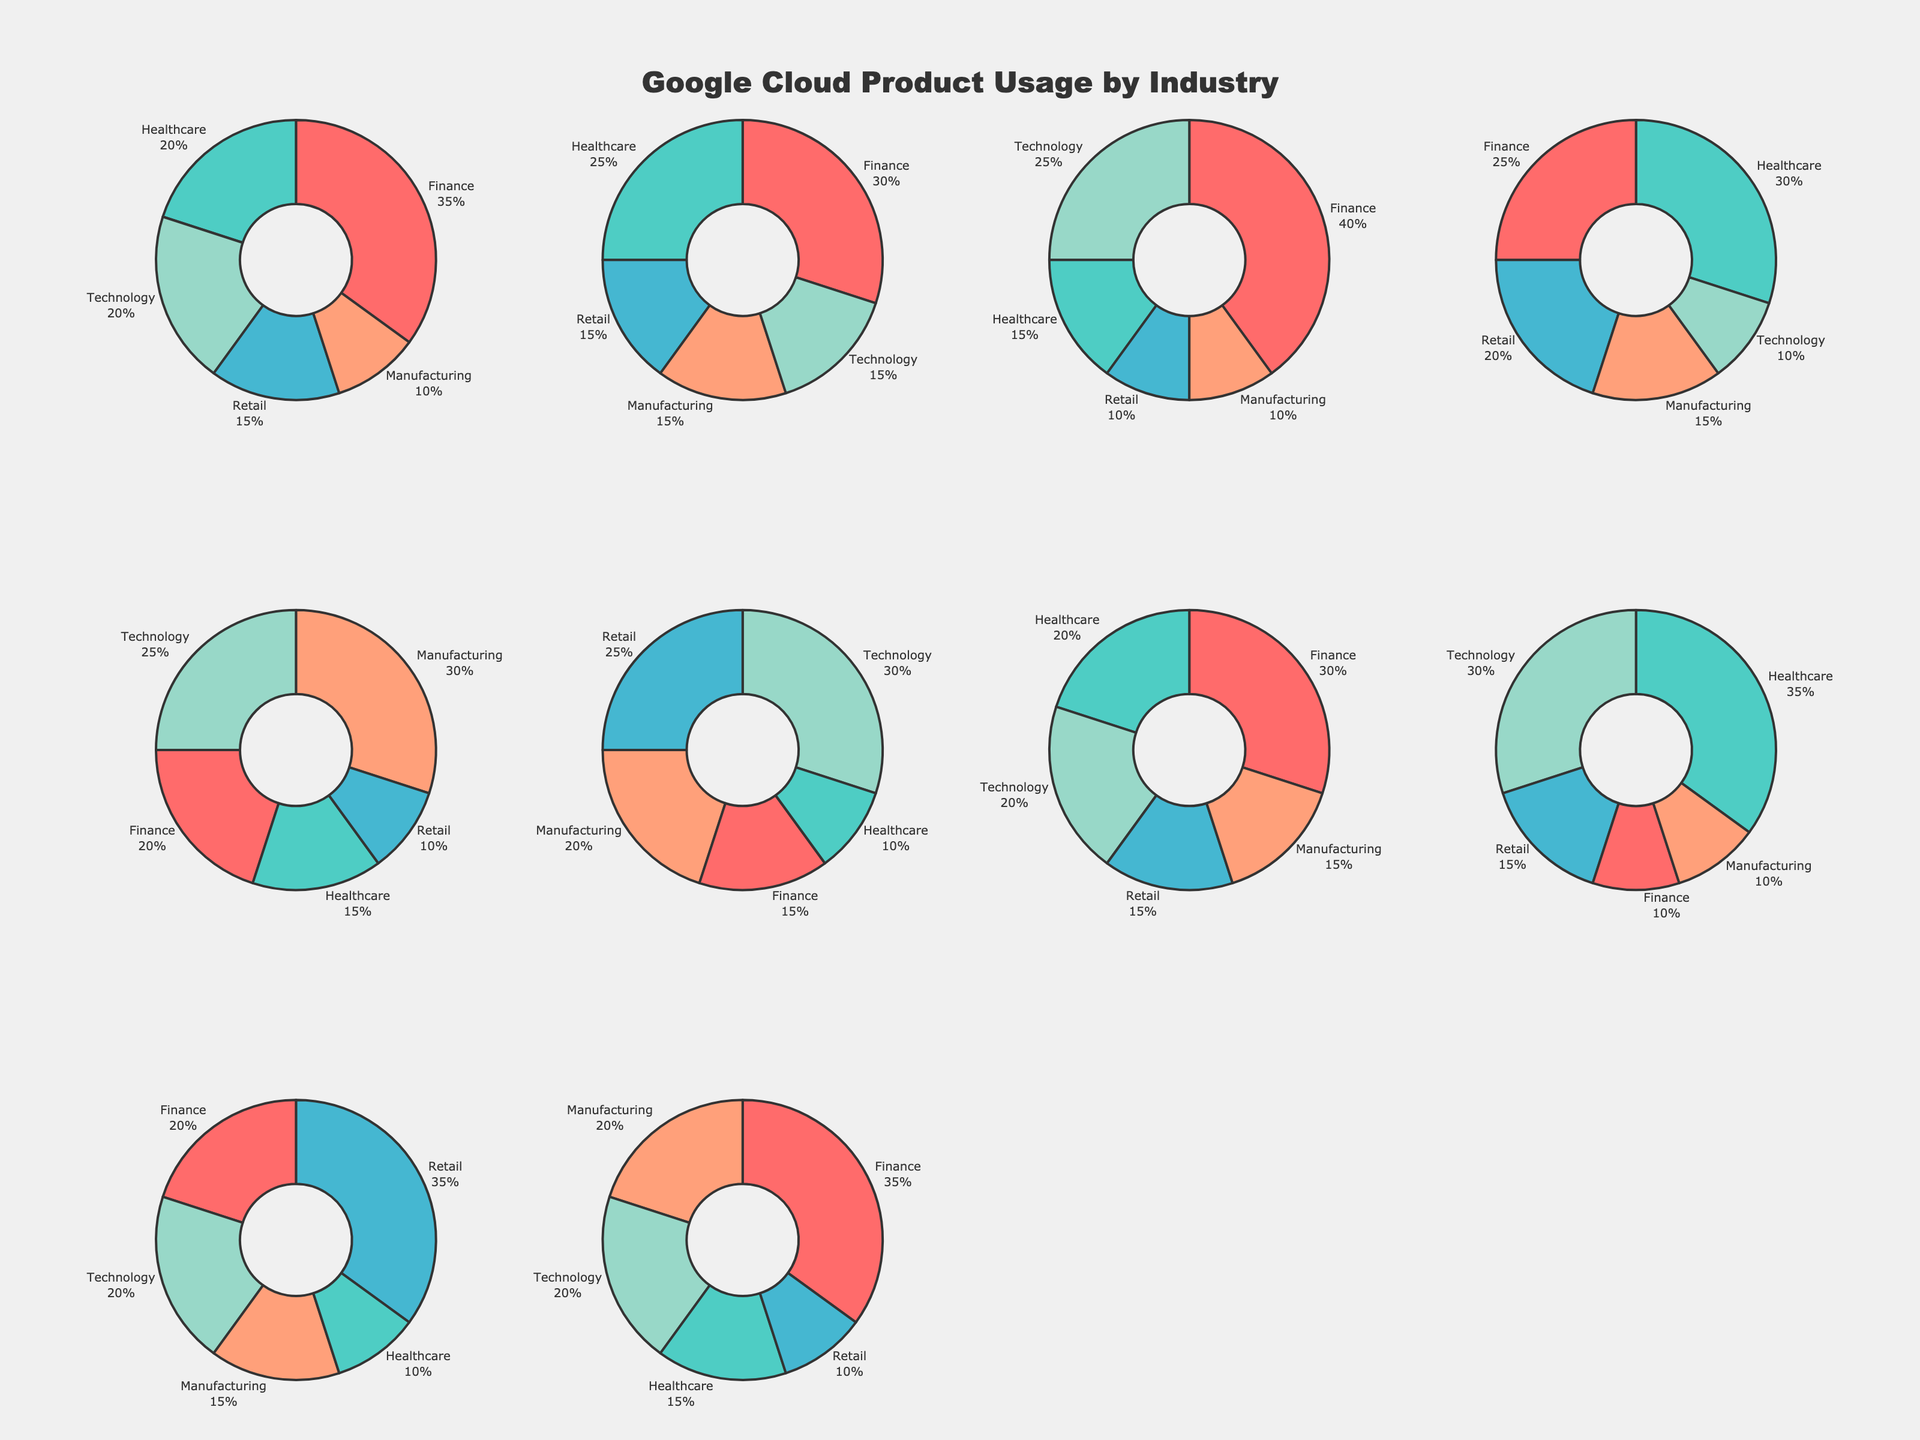What is the title of the figure? The title is usually displayed prominently at the top of the figure. From the given description, it is stated that the title is "Google Cloud Product Usage by Industry".
Answer: Google Cloud Product Usage by Industry Which industry sector has the highest usage of Google Cloud Storage? To find this, locate the pie chart for Google Cloud Storage and find the sector with the largest slice. According to the data, the Finance industry has the highest usage with 35%.
Answer: Finance Which industry has the lowest usage of BigQuery? Look at the pie chart for BigQuery and identify the sector with the smallest slice. According to the data, both Retail and Manufacturing have the lowest usage of BigQuery at 10%.
Answer: Retail and Manufacturing What is the average usage percentage of Cloud Functions across all industries? First, sum the usage percentages for Cloud Functions across all listed industries: (15 + 10 + 25 + 20 + 30) = 100. Then, divide this sum by the number of industries (5). 100 / 5 = 20%.
Answer: 20% Which Google Cloud product shows the highest usage in the Healthcare industry? Examine the slices within the pie chart for the Healthcare industry and identify which product has the largest slice. In the data, Cloud AI Platform shows the highest usage at 35%.
Answer: Cloud AI Platform Compare the usage of Kubernetes Engine between Healthcare and Manufacturing industries. Which has higher usage? Identify the slices for Kubernetes Engine in both Healthcare and Manufacturing pie charts. Healthcare has 15% while Manufacturing has 30%. Manufacturing's usage is higher.
Answer: Manufacturing What percentage of the Technology sector uses Cloud CDN? Check the Technology pie chart and look for the slice representing Cloud CDN. According to the data, it is 20%.
Answer: 20% If you sum the usage percentages of Cloud Pub/Sub in Finance, Healthcare and Retail sectors, what would be the result? Add the usage percentages of Cloud Pub/Sub in the Finance (30), Healthcare (20), and Retail (15) sectors. 30 + 20 + 15 = 65%.
Answer: 65% How does Cloud AI Platform's usage in the Technology industry compare with that in the Finance industry? For Cloud AI Platform, locate and compare the slice sizes for Technology and Finance sectors. Technology's percentage is 30%, while Finance's percentage is 10%. Therefore, Cloud AI Platform is used more in Technology by 20 percentage points.
Answer: Technology has 20% more usage What are the three Google Cloud products with the lowest usage in the Retail industry? Examine the pie chart representing the Retail industry's usage. According to the data, the three products with the lowest usage percentages are BigQuery (10%), Kubernetes Engine (10%), and Cloud Dataflow (10%).
Answer: BigQuery, Kubernetes Engine, and Cloud Dataflow 